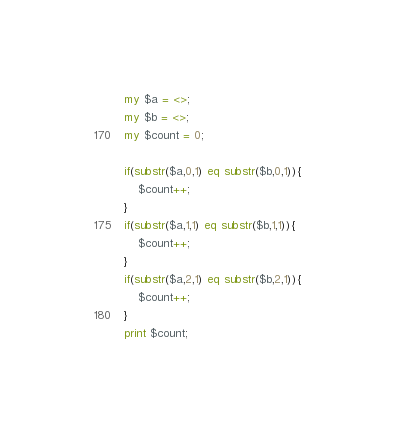Convert code to text. <code><loc_0><loc_0><loc_500><loc_500><_Perl_>my $a = <>;
my $b = <>;
my $count = 0;

if(substr($a,0,1) eq substr($b,0,1)){
	$count++;
}
if(substr($a,1,1) eq substr($b,1,1)){
	$count++;
}
if(substr($a,2,1) eq substr($b,2,1)){
	$count++;
}
print $count;</code> 